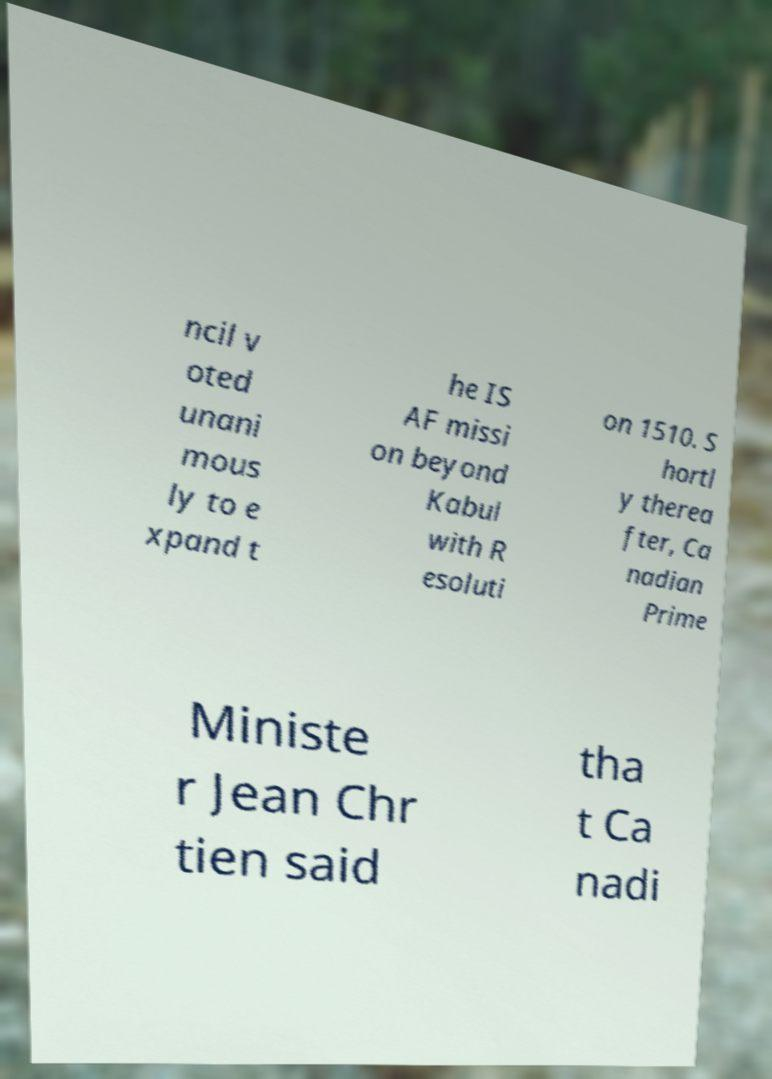What messages or text are displayed in this image? I need them in a readable, typed format. ncil v oted unani mous ly to e xpand t he IS AF missi on beyond Kabul with R esoluti on 1510. S hortl y therea fter, Ca nadian Prime Ministe r Jean Chr tien said tha t Ca nadi 